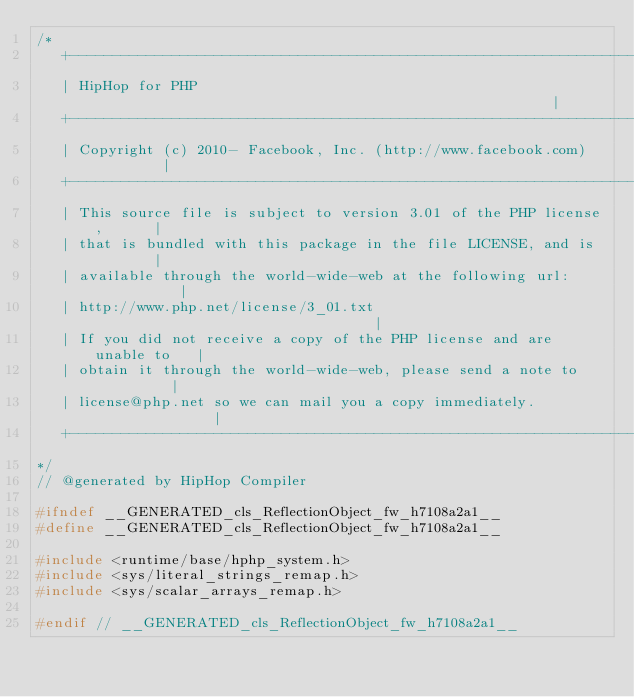Convert code to text. <code><loc_0><loc_0><loc_500><loc_500><_C_>/*
   +----------------------------------------------------------------------+
   | HipHop for PHP                                                       |
   +----------------------------------------------------------------------+
   | Copyright (c) 2010- Facebook, Inc. (http://www.facebook.com)         |
   +----------------------------------------------------------------------+
   | This source file is subject to version 3.01 of the PHP license,      |
   | that is bundled with this package in the file LICENSE, and is        |
   | available through the world-wide-web at the following url:           |
   | http://www.php.net/license/3_01.txt                                  |
   | If you did not receive a copy of the PHP license and are unable to   |
   | obtain it through the world-wide-web, please send a note to          |
   | license@php.net so we can mail you a copy immediately.               |
   +----------------------------------------------------------------------+
*/
// @generated by HipHop Compiler

#ifndef __GENERATED_cls_ReflectionObject_fw_h7108a2a1__
#define __GENERATED_cls_ReflectionObject_fw_h7108a2a1__

#include <runtime/base/hphp_system.h>
#include <sys/literal_strings_remap.h>
#include <sys/scalar_arrays_remap.h>

#endif // __GENERATED_cls_ReflectionObject_fw_h7108a2a1__
</code> 